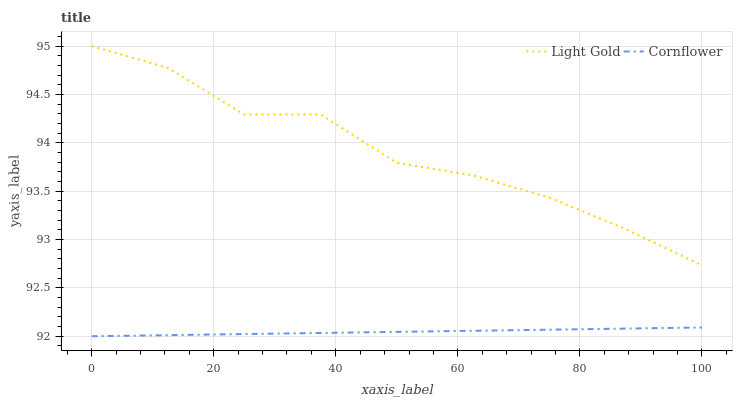Does Cornflower have the minimum area under the curve?
Answer yes or no. Yes. Does Light Gold have the maximum area under the curve?
Answer yes or no. Yes. Does Light Gold have the minimum area under the curve?
Answer yes or no. No. Is Cornflower the smoothest?
Answer yes or no. Yes. Is Light Gold the roughest?
Answer yes or no. Yes. Is Light Gold the smoothest?
Answer yes or no. No. Does Cornflower have the lowest value?
Answer yes or no. Yes. Does Light Gold have the lowest value?
Answer yes or no. No. Does Light Gold have the highest value?
Answer yes or no. Yes. Is Cornflower less than Light Gold?
Answer yes or no. Yes. Is Light Gold greater than Cornflower?
Answer yes or no. Yes. Does Cornflower intersect Light Gold?
Answer yes or no. No. 